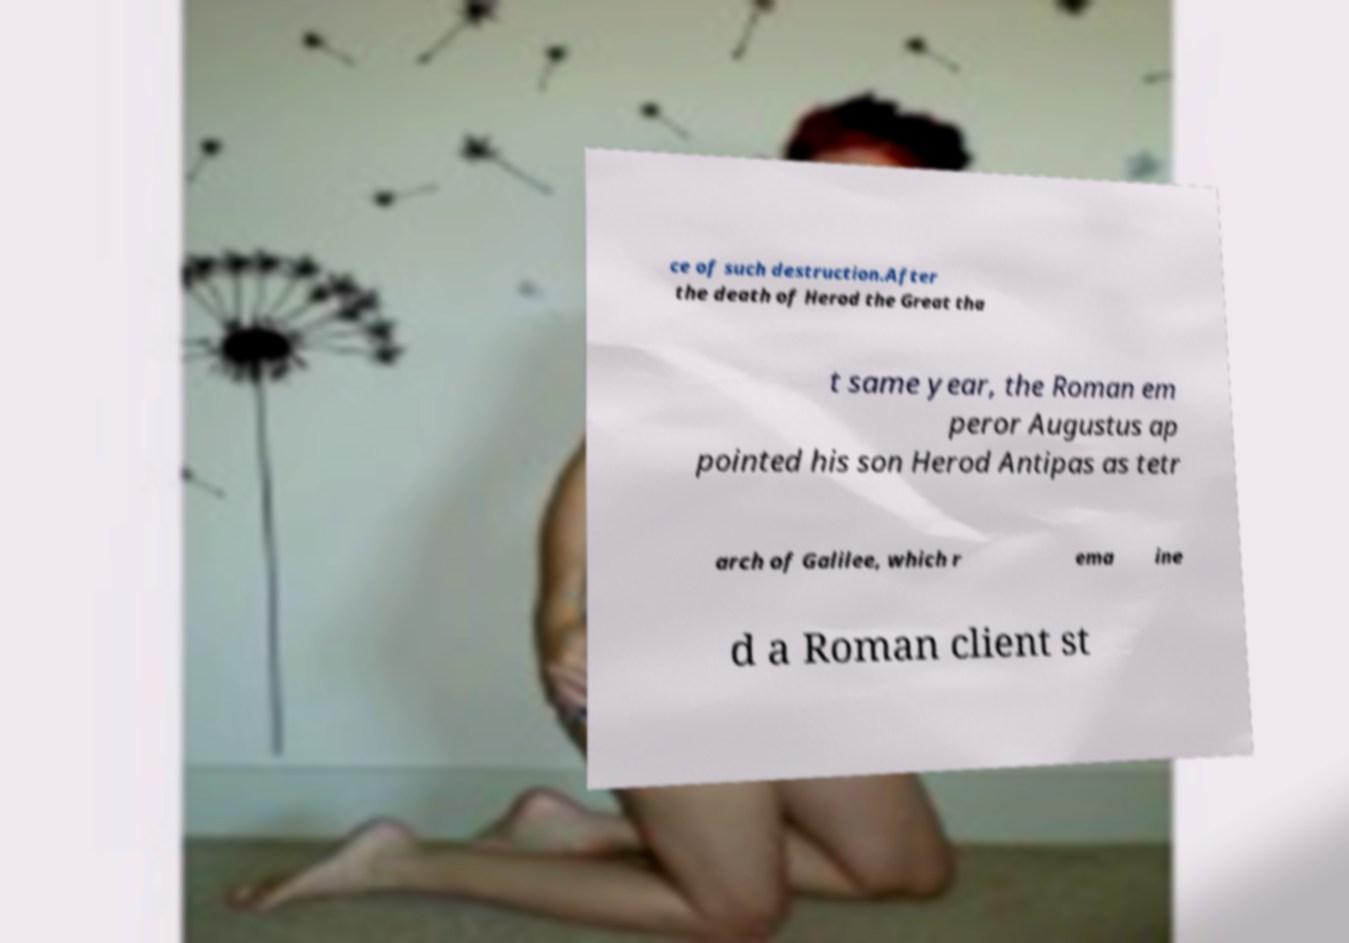Please read and relay the text visible in this image. What does it say? ce of such destruction.After the death of Herod the Great tha t same year, the Roman em peror Augustus ap pointed his son Herod Antipas as tetr arch of Galilee, which r ema ine d a Roman client st 